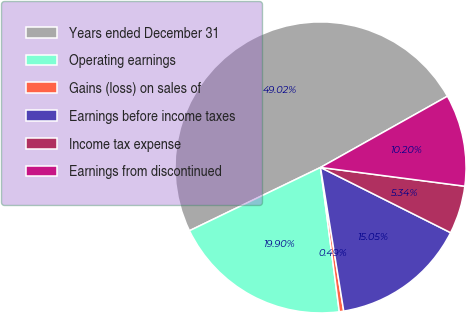Convert chart to OTSL. <chart><loc_0><loc_0><loc_500><loc_500><pie_chart><fcel>Years ended December 31<fcel>Operating earnings<fcel>Gains (loss) on sales of<fcel>Earnings before income taxes<fcel>Income tax expense<fcel>Earnings from discontinued<nl><fcel>49.02%<fcel>19.9%<fcel>0.49%<fcel>15.05%<fcel>5.34%<fcel>10.2%<nl></chart> 